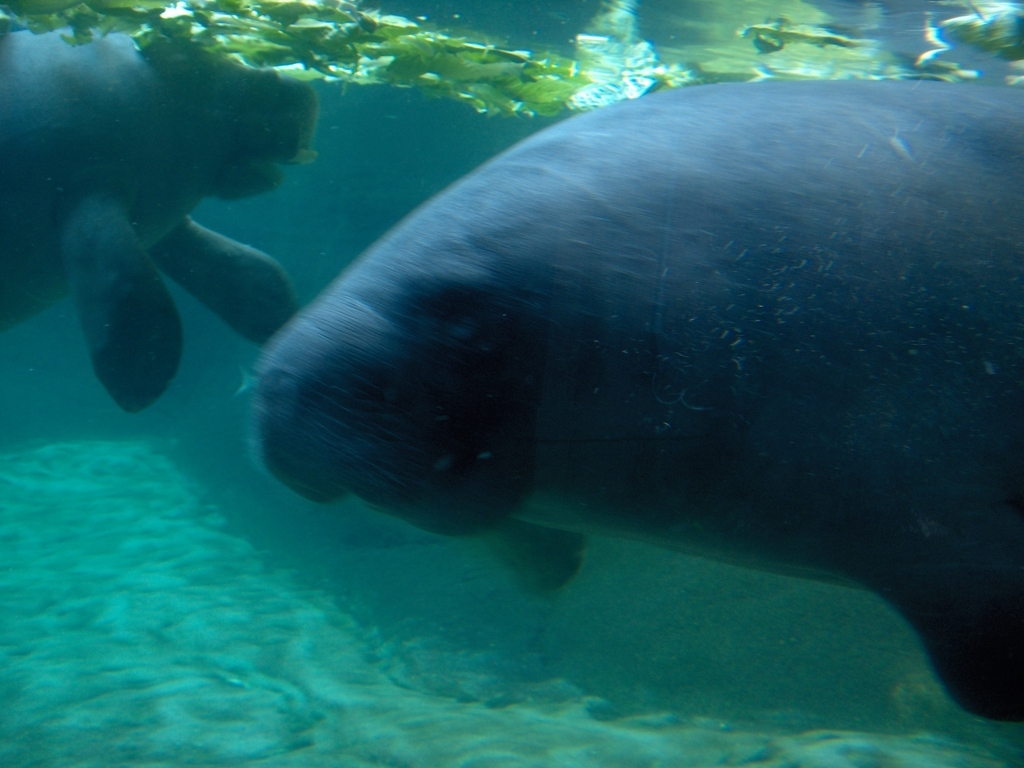Is the quality of this image excellent? The image quality is not excellent; it's a bit blurry and there are artifacts that suggest it might have been taken through a thick glass barrier or underwater. The lighting appears natural, but the clarity is compromised, which affects the overall quality of the image. 